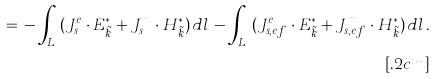Convert formula to latex. <formula><loc_0><loc_0><loc_500><loc_500>= \, - \int _ { L _ { s } } ( { J } _ { s } ^ { e } \cdot { E } _ { \tilde { k } } ^ { * } + { J } _ { s } ^ { m } \cdot { H } _ { \tilde { k } } ^ { * } ) \, d l \, - \int _ { L _ { b } } ( { J } _ { s , e f } ^ { e } \cdot { E } _ { \tilde { k } } ^ { * } + { J } _ { s , e f } ^ { m } \cdot { H } _ { \tilde { k } } ^ { * } ) \, d l \, . \\ [ . 2 c m ]</formula> 